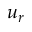Convert formula to latex. <formula><loc_0><loc_0><loc_500><loc_500>u _ { r }</formula> 